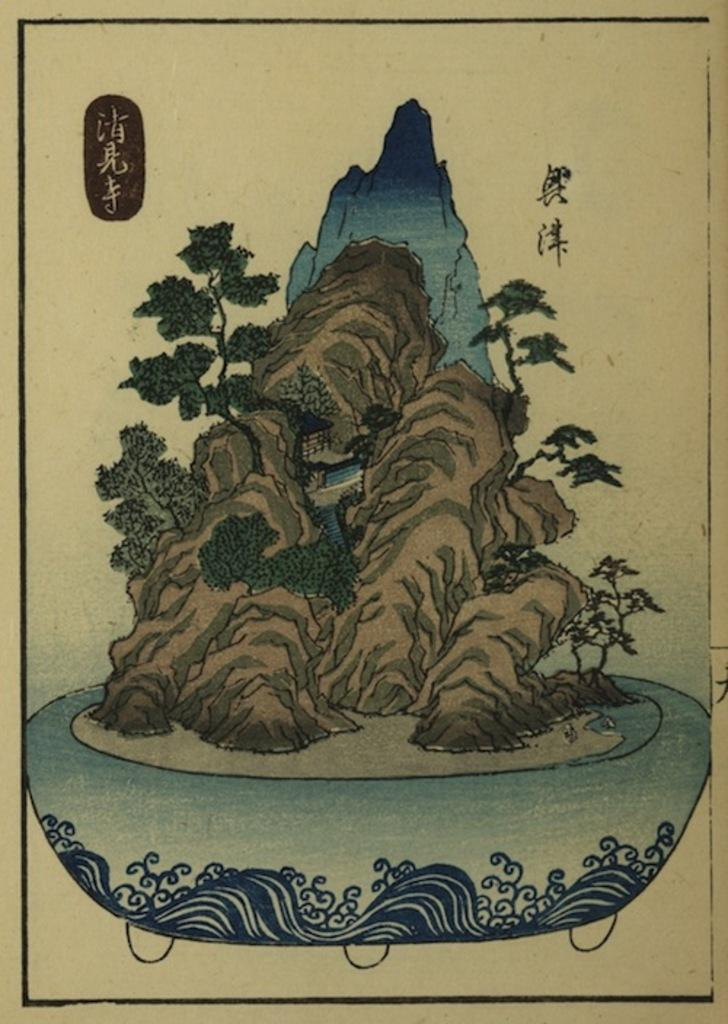What is depicted on the poster in the image? There is a poster of a mountain in the image. What type of natural scenery can be seen in the image? There are trees visible in the image. What color is the orange that the fireman is holding in the image? There is no orange or fireman present in the image; it only features a poster of a mountain and trees. 